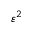Convert formula to latex. <formula><loc_0><loc_0><loc_500><loc_500>\varepsilon ^ { 2 }</formula> 